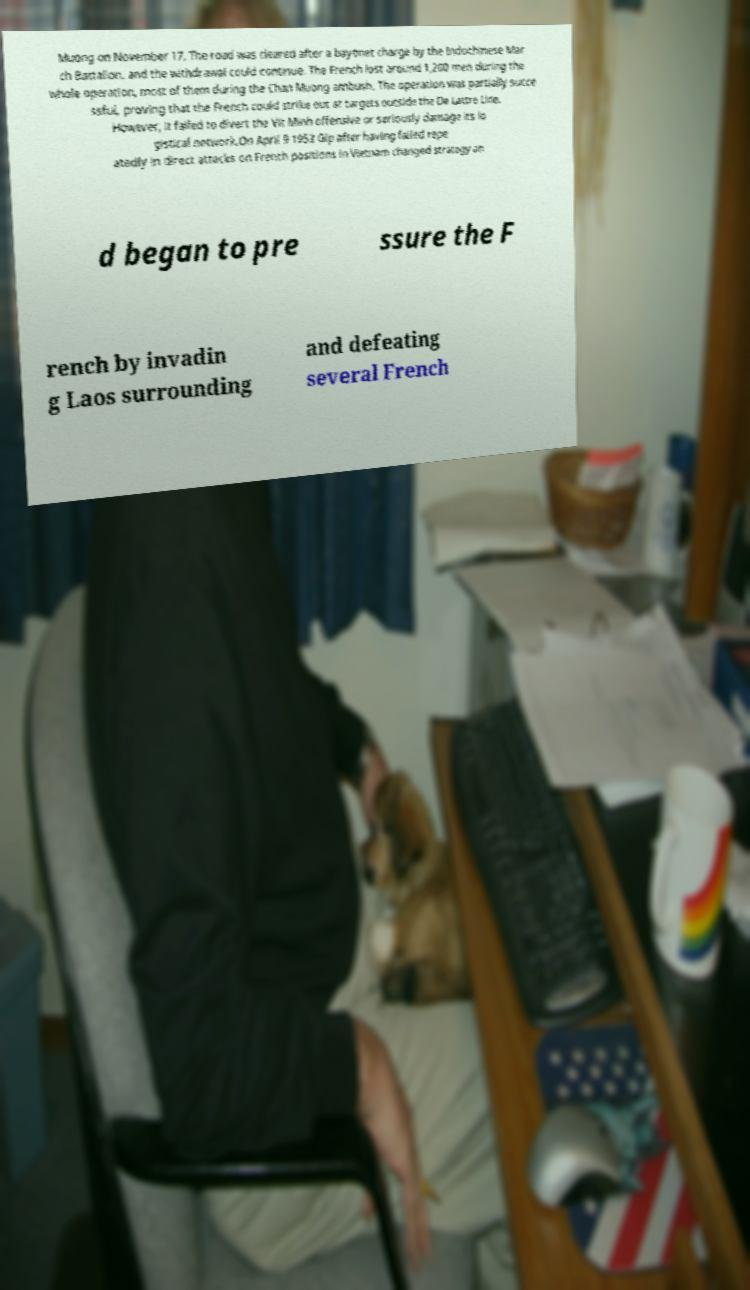For documentation purposes, I need the text within this image transcribed. Could you provide that? Muong on November 17. The road was cleared after a bayonet charge by the Indochinese Mar ch Battalion, and the withdrawal could continue. The French lost around 1,200 men during the whole operation, most of them during the Chan Muong ambush. The operation was partially succe ssful, proving that the French could strike out at targets outside the De Lattre Line. However, it failed to divert the Vit Minh offensive or seriously damage its lo gistical network.On April 9 1953 Gip after having failed repe atedly in direct attacks on French positions in Vietnam changed strategy an d began to pre ssure the F rench by invadin g Laos surrounding and defeating several French 